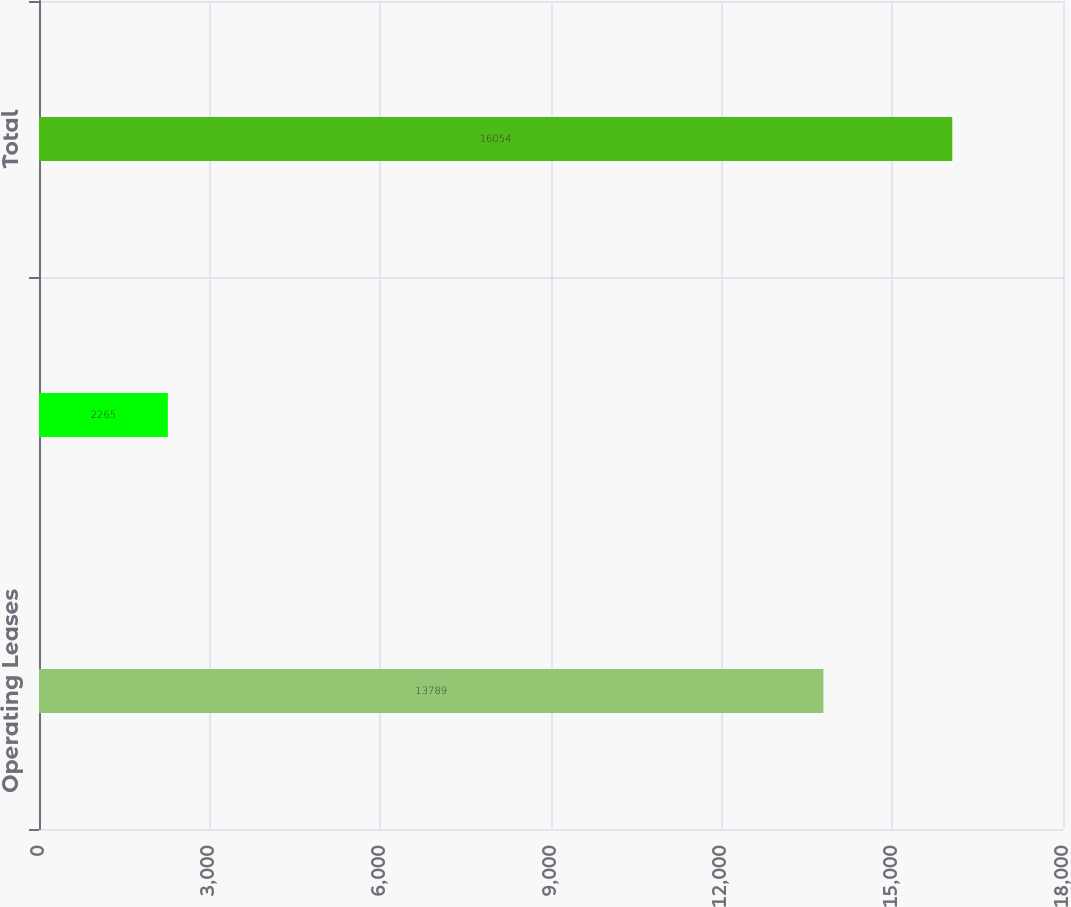Convert chart. <chart><loc_0><loc_0><loc_500><loc_500><bar_chart><fcel>Operating Leases<fcel>Purchase Obligations<fcel>Total<nl><fcel>13789<fcel>2265<fcel>16054<nl></chart> 